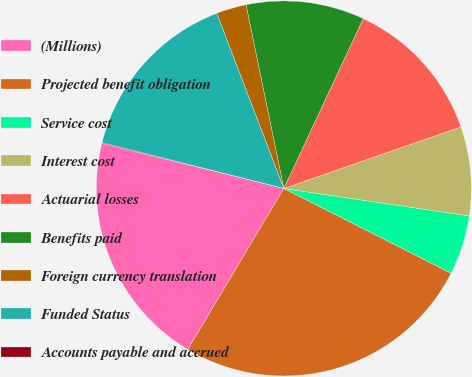Convert chart. <chart><loc_0><loc_0><loc_500><loc_500><pie_chart><fcel>(Millions)<fcel>Projected benefit obligation<fcel>Service cost<fcel>Interest cost<fcel>Actuarial losses<fcel>Benefits paid<fcel>Foreign currency translation<fcel>Funded Status<fcel>Accounts payable and accrued<nl><fcel>20.31%<fcel>26.09%<fcel>5.12%<fcel>7.66%<fcel>12.72%<fcel>10.19%<fcel>2.59%<fcel>15.25%<fcel>0.06%<nl></chart> 